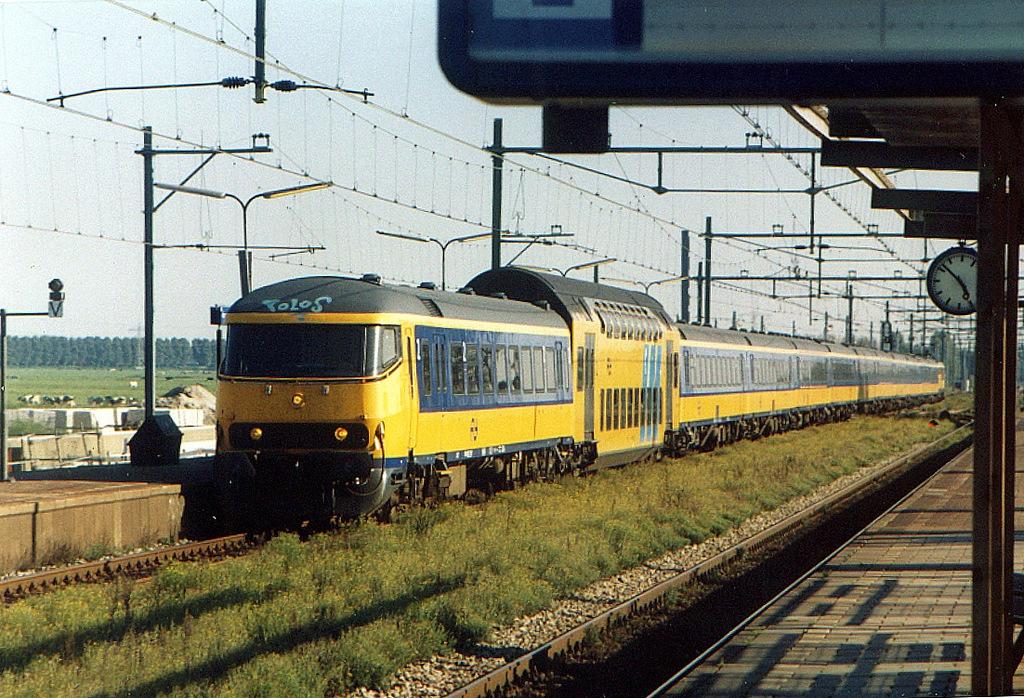What time is shown on the clock?
Provide a succinct answer. 4:52. 